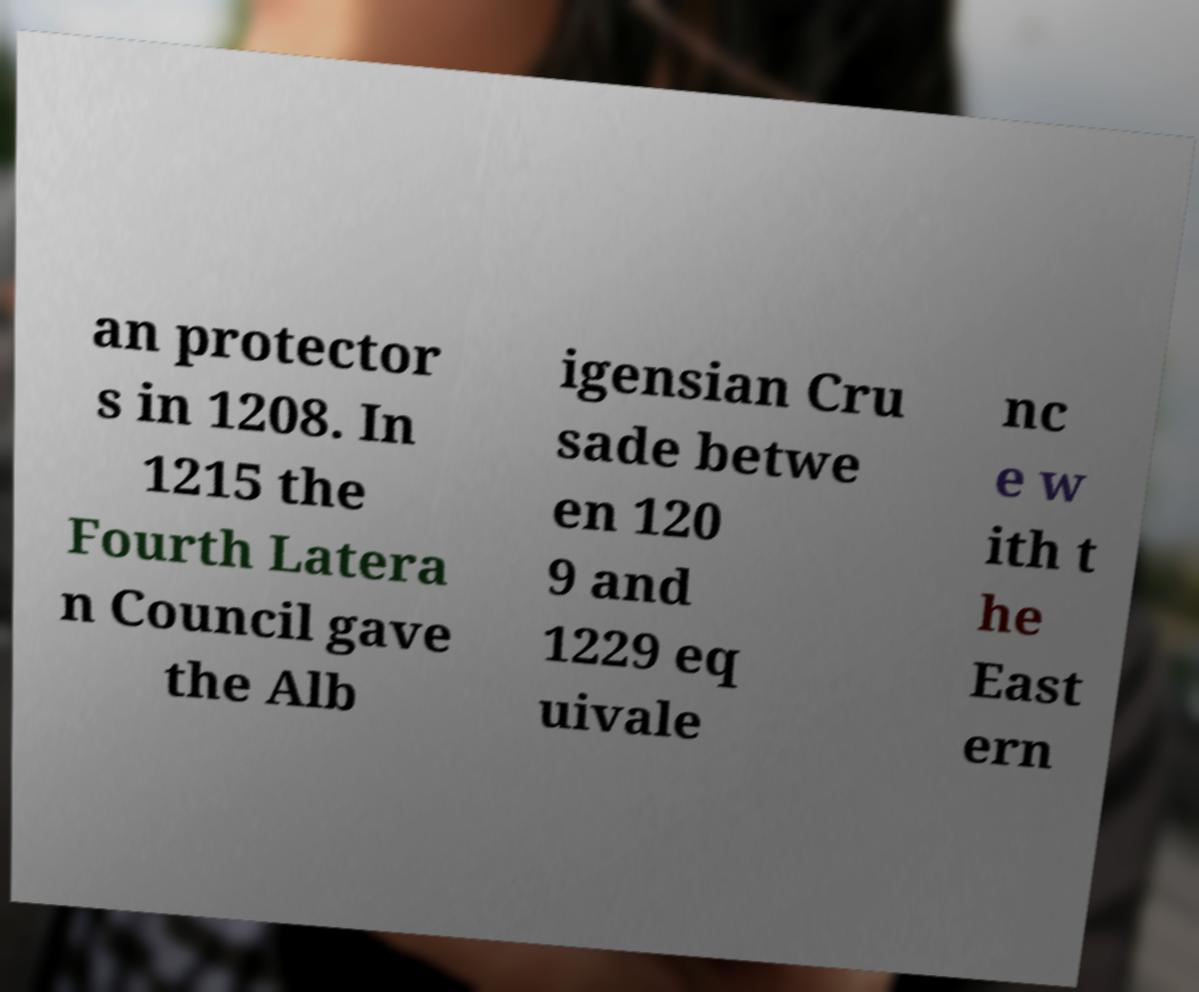Can you accurately transcribe the text from the provided image for me? an protector s in 1208. In 1215 the Fourth Latera n Council gave the Alb igensian Cru sade betwe en 120 9 and 1229 eq uivale nc e w ith t he East ern 